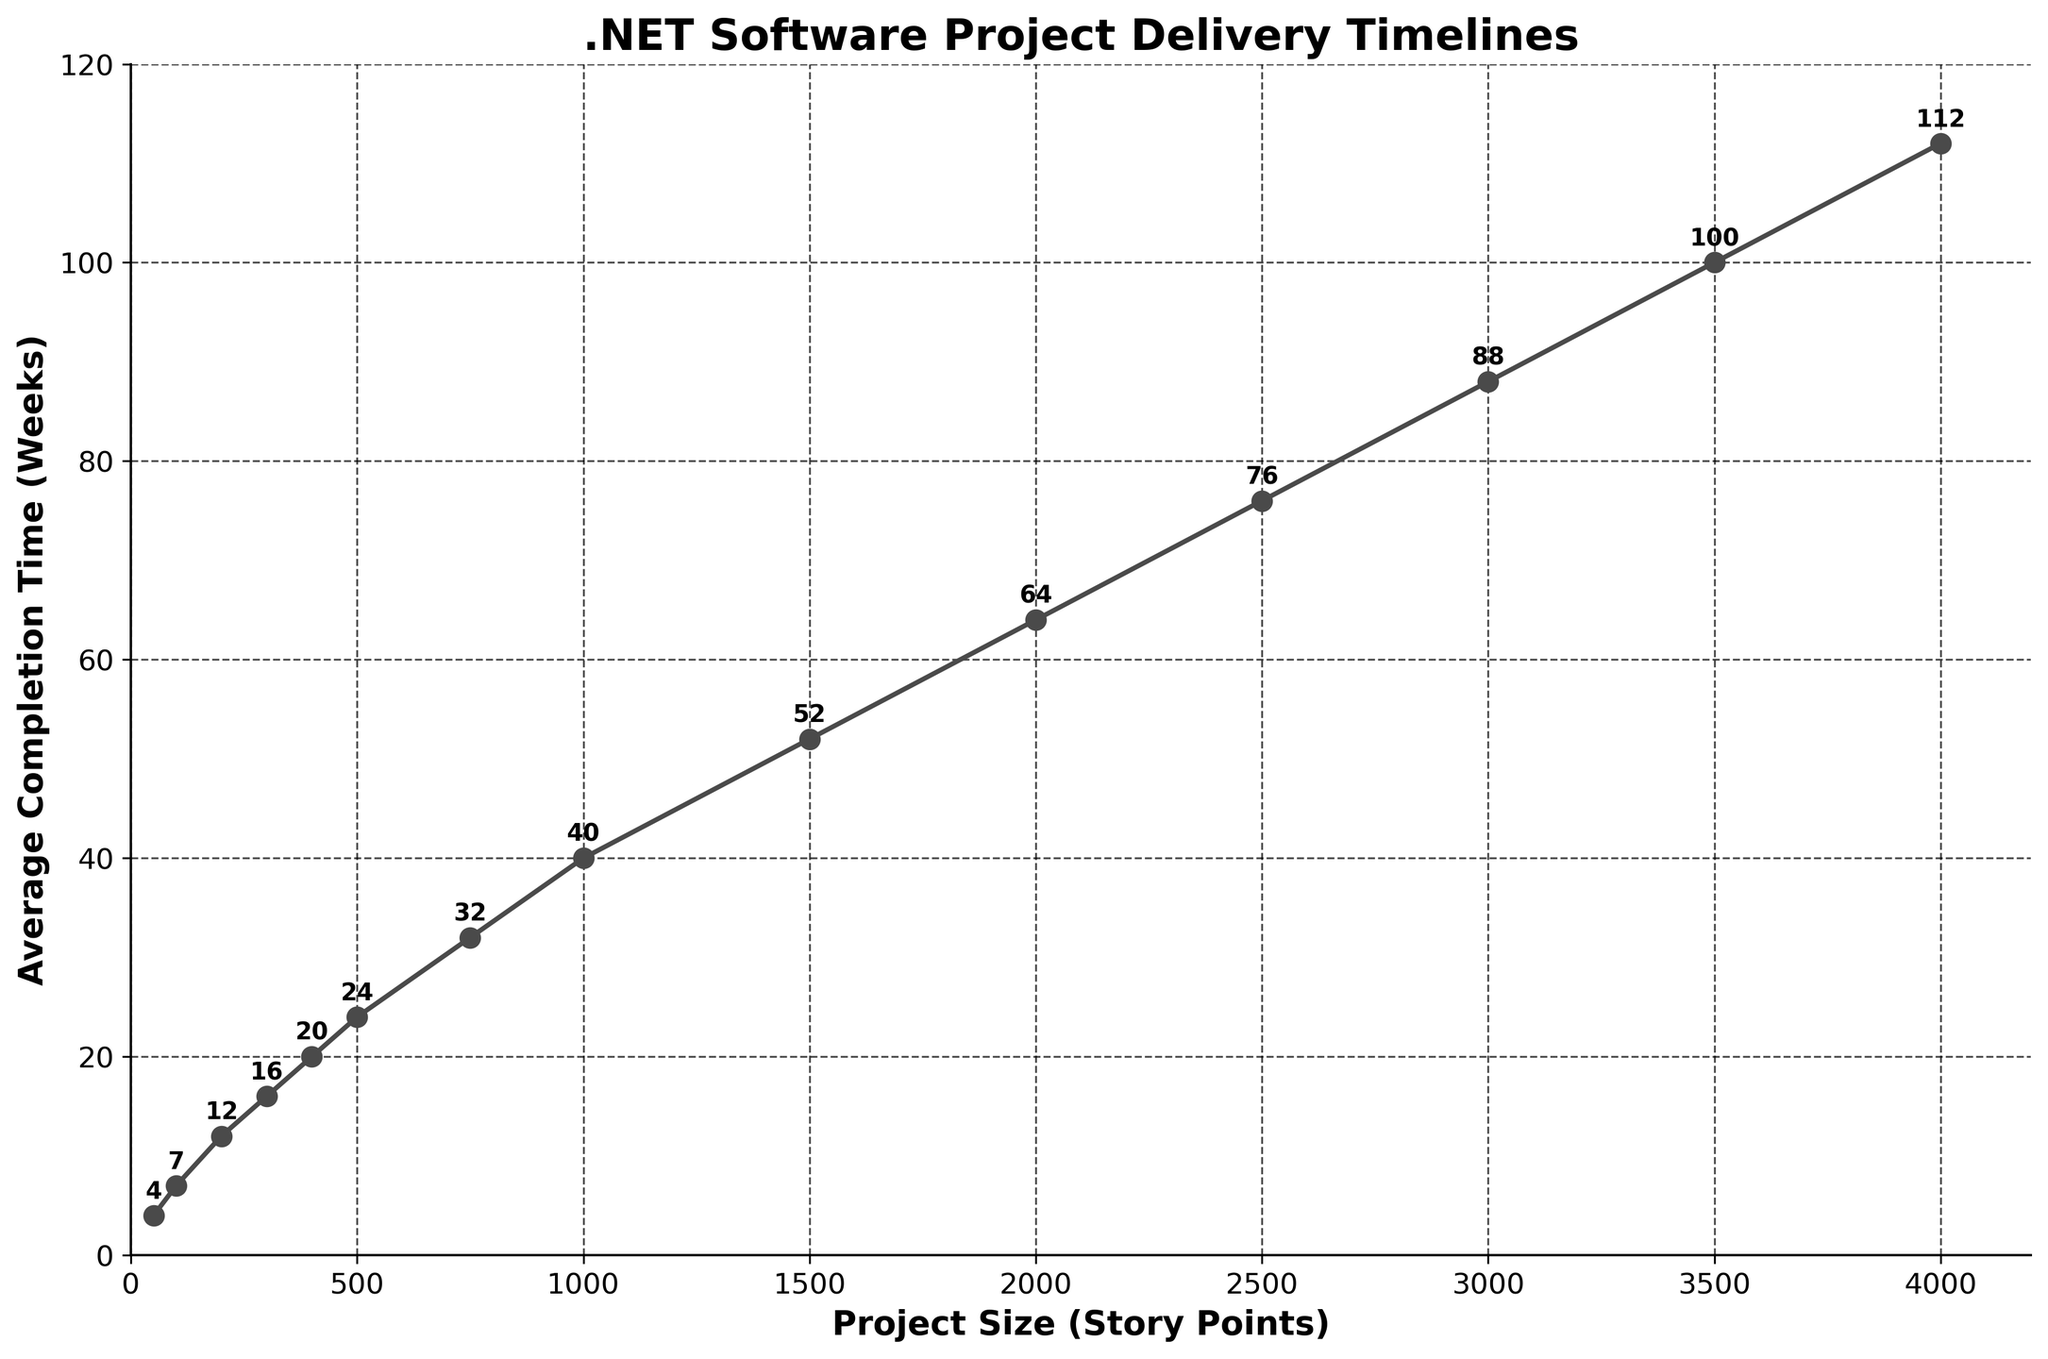What is the average completion time for a project size of 500 story points? Locate the point corresponding to the project size of 500 story points on the x-axis and read off the corresponding value on the y-axis.
Answer: 24 weeks Between project sizes of 1000 and 1500 story points, which one has a higher completion time and by how much? Read off the completion times directly: 1000 story points correspond to 40 weeks and 1500 story points correspond to 52 weeks. Subtract 40 from 52.
Answer: 1500 story points, 12 weeks What trend do you observe in the completion times as the project size increases from 50 to 4000 story points? Observe the slope of the line in the plot. The completion time increases as the project size increases.
Answer: Increasing trend At what project size does the average completion time exceed 50 weeks? Identify the point on the x-axis where the y-axis value exceeds 50 weeks. The first such point is at 1500 story points with an average completion time of 52 weeks.
Answer: 1500 story points What is the difference in completion time between the project sizes of 2000 and 3000 story points? Read off the completion times for 2000 story points (64 weeks) and 3000 story points (88 weeks). Subtract 64 from 88.
Answer: 24 weeks For project sizes smaller than 1000 story points, which project size has the lowest average completion time, and what is that time? Scan the plot for project sizes below 1000 story points. The smallest project size is 50 story points, and it corresponds to the lowest time.
Answer: 50 story points, 4 weeks Is there a project size where the completion time doubles from the previous data point? If so, identify the sizes and times. Examine each data point to see if the completion time is twice that of the previous point. The completion time at 300 story points (16 weeks) is more than double that at 100 story points (7 weeks).
Answer: 4000 story points, 112 weeks Calculate the average completion time for project sizes in the range of 750 to 1500 story points. Identify and sum the completion times for 750 (32 weeks), 1000 (40 weeks), and 1500 (52 weeks). Divide by the number of data points (3).
Answer: (32 + 40 + 52) / 3 = 41 weeks How does the completion time change as the project size increases from 2000 to 4000 story points? Track the values for 2000 (64 weeks), 2500 (76 weeks), 3000 (88 weeks), 3500 (100 weeks), and 4000 (112 weeks). There is a consistent increase.
Answer: Consistently increasing 